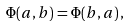<formula> <loc_0><loc_0><loc_500><loc_500>\Phi ( a , b ) = \Phi ( b , a ) \, ,</formula> 